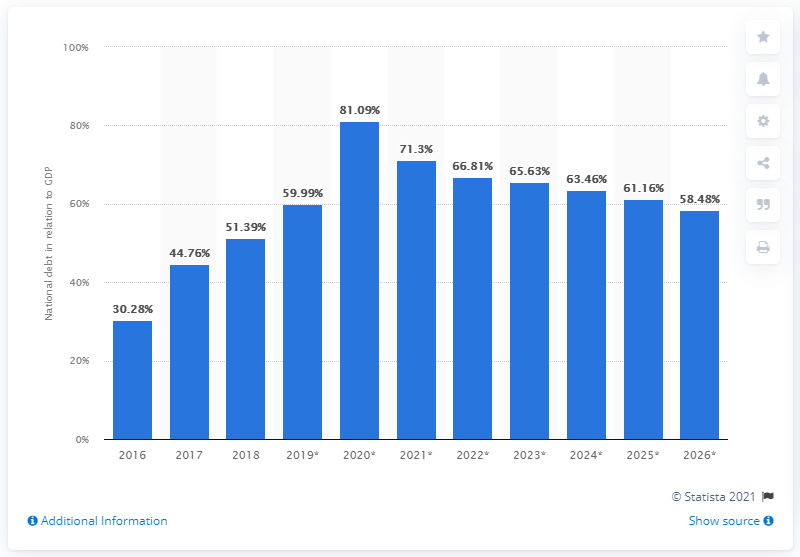Highlight a few significant elements in this photo. In 2018, the national debt of Oman accounted for 51.39% of the country's GDP. 